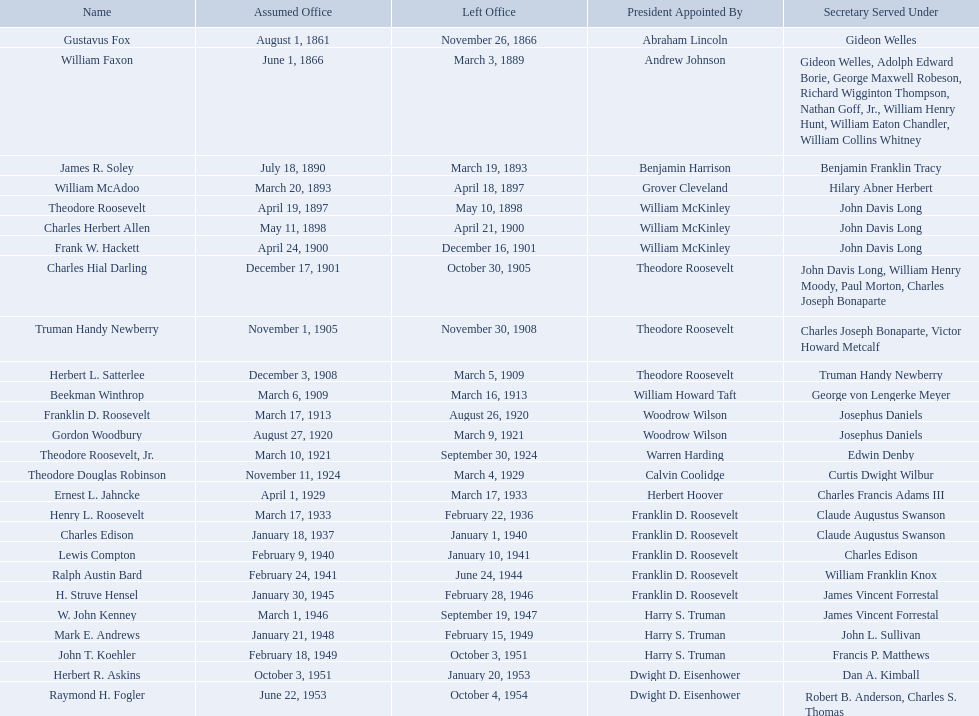Who were all the assistant secretary's of the navy? Gustavus Fox, William Faxon, James R. Soley, William McAdoo, Theodore Roosevelt, Charles Herbert Allen, Frank W. Hackett, Charles Hial Darling, Truman Handy Newberry, Herbert L. Satterlee, Beekman Winthrop, Franklin D. Roosevelt, Gordon Woodbury, Theodore Roosevelt, Jr., Theodore Douglas Robinson, Ernest L. Jahncke, Henry L. Roosevelt, Charles Edison, Lewis Compton, Ralph Austin Bard, H. Struve Hensel, W. John Kenney, Mark E. Andrews, John T. Koehler, Herbert R. Askins, Raymond H. Fogler. What are the various dates they left office in? November 26, 1866, March 3, 1889, March 19, 1893, April 18, 1897, May 10, 1898, April 21, 1900, December 16, 1901, October 30, 1905, November 30, 1908, March 5, 1909, March 16, 1913, August 26, 1920, March 9, 1921, September 30, 1924, March 4, 1929, March 17, 1933, February 22, 1936, January 1, 1940, January 10, 1941, June 24, 1944, February 28, 1946, September 19, 1947, February 15, 1949, October 3, 1951, January 20, 1953, October 4, 1954. Of these dates, which was the date raymond h. fogler left office in? October 4, 1954. Who were all the assistant secretaries of the navy throughout the 20th century? Charles Herbert Allen, Frank W. Hackett, Charles Hial Darling, Truman Handy Newberry, Herbert L. Satterlee, Beekman Winthrop, Franklin D. Roosevelt, Gordon Woodbury, Theodore Roosevelt, Jr., Theodore Douglas Robinson, Ernest L. Jahncke, Henry L. Roosevelt, Charles Edison, Lewis Compton, Ralph Austin Bard, H. Struve Hensel, W. John Kenney, Mark E. Andrews, John T. Koehler, Herbert R. Askins, Raymond H. Fogler. When was assistant secretary of the navy raymond h. fogler appointed to his position? June 22, 1953. When did assistant secretary of the navy raymond h. fogler step down from his role? October 4, 1954. Can you list the assistant secretaries of the navy from the 20th century? Charles Herbert Allen, Frank W. Hackett, Charles Hial Darling, Truman Handy Newberry, Herbert L. Satterlee, Beekman Winthrop, Franklin D. Roosevelt, Gordon Woodbury, Theodore Roosevelt, Jr., Theodore Douglas Robinson, Ernest L. Jahncke, Henry L. Roosevelt, Charles Edison, Lewis Compton, Ralph Austin Bard, H. Struve Hensel, W. John Kenney, Mark E. Andrews, John T. Koehler, Herbert R. Askins, Raymond H. Fogler. When was raymond h. fogler's appointment as assistant secretary of the navy? June 22, 1953. When did he depart from this position? October 4, 1954. What are the complete names? Gustavus Fox, William Faxon, James R. Soley, William McAdoo, Theodore Roosevelt, Charles Herbert Allen, Frank W. Hackett, Charles Hial Darling, Truman Handy Newberry, Herbert L. Satterlee, Beekman Winthrop, Franklin D. Roosevelt, Gordon Woodbury, Theodore Roosevelt, Jr., Theodore Douglas Robinson, Ernest L. Jahncke, Henry L. Roosevelt, Charles Edison, Lewis Compton, Ralph Austin Bard, H. Struve Hensel, W. John Kenney, Mark E. Andrews, John T. Koehler, Herbert R. Askins, Raymond H. Fogler. When was their term in office finished? November 26, 1866, March 3, 1889, March 19, 1893, April 18, 1897, May 10, 1898, April 21, 1900, December 16, 1901, October 30, 1905, November 30, 1908, March 5, 1909, March 16, 1913, August 26, 1920, March 9, 1921, September 30, 1924, March 4, 1929, March 17, 1933, February 22, 1936, January 1, 1940, January 10, 1941, June 24, 1944, February 28, 1946, September 19, 1947, February 15, 1949, October 3, 1951, January 20, 1953, October 4, 1954. And when did raymond h. fogler depart? October 4, 1954. Can you provide the full names? Gustavus Fox, William Faxon, James R. Soley, William McAdoo, Theodore Roosevelt, Charles Herbert Allen, Frank W. Hackett, Charles Hial Darling, Truman Handy Newberry, Herbert L. Satterlee, Beekman Winthrop, Franklin D. Roosevelt, Gordon Woodbury, Theodore Roosevelt, Jr., Theodore Douglas Robinson, Ernest L. Jahncke, Henry L. Roosevelt, Charles Edison, Lewis Compton, Ralph Austin Bard, H. Struve Hensel, W. John Kenney, Mark E. Andrews, John T. Koehler, Herbert R. Askins, Raymond H. Fogler. Would you be able to parse every entry in this table? {'header': ['Name', 'Assumed Office', 'Left Office', 'President Appointed By', 'Secretary Served Under'], 'rows': [['Gustavus Fox', 'August 1, 1861', 'November 26, 1866', 'Abraham Lincoln', 'Gideon Welles'], ['William Faxon', 'June 1, 1866', 'March 3, 1889', 'Andrew Johnson', 'Gideon Welles, Adolph Edward Borie, George Maxwell Robeson, Richard Wigginton Thompson, Nathan Goff, Jr., William Henry Hunt, William Eaton Chandler, William Collins Whitney'], ['James R. Soley', 'July 18, 1890', 'March 19, 1893', 'Benjamin Harrison', 'Benjamin Franklin Tracy'], ['William McAdoo', 'March 20, 1893', 'April 18, 1897', 'Grover Cleveland', 'Hilary Abner Herbert'], ['Theodore Roosevelt', 'April 19, 1897', 'May 10, 1898', 'William McKinley', 'John Davis Long'], ['Charles Herbert Allen', 'May 11, 1898', 'April 21, 1900', 'William McKinley', 'John Davis Long'], ['Frank W. Hackett', 'April 24, 1900', 'December 16, 1901', 'William McKinley', 'John Davis Long'], ['Charles Hial Darling', 'December 17, 1901', 'October 30, 1905', 'Theodore Roosevelt', 'John Davis Long, William Henry Moody, Paul Morton, Charles Joseph Bonaparte'], ['Truman Handy Newberry', 'November 1, 1905', 'November 30, 1908', 'Theodore Roosevelt', 'Charles Joseph Bonaparte, Victor Howard Metcalf'], ['Herbert L. Satterlee', 'December 3, 1908', 'March 5, 1909', 'Theodore Roosevelt', 'Truman Handy Newberry'], ['Beekman Winthrop', 'March 6, 1909', 'March 16, 1913', 'William Howard Taft', 'George von Lengerke Meyer'], ['Franklin D. Roosevelt', 'March 17, 1913', 'August 26, 1920', 'Woodrow Wilson', 'Josephus Daniels'], ['Gordon Woodbury', 'August 27, 1920', 'March 9, 1921', 'Woodrow Wilson', 'Josephus Daniels'], ['Theodore Roosevelt, Jr.', 'March 10, 1921', 'September 30, 1924', 'Warren Harding', 'Edwin Denby'], ['Theodore Douglas Robinson', 'November 11, 1924', 'March 4, 1929', 'Calvin Coolidge', 'Curtis Dwight Wilbur'], ['Ernest L. Jahncke', 'April 1, 1929', 'March 17, 1933', 'Herbert Hoover', 'Charles Francis Adams III'], ['Henry L. Roosevelt', 'March 17, 1933', 'February 22, 1936', 'Franklin D. Roosevelt', 'Claude Augustus Swanson'], ['Charles Edison', 'January 18, 1937', 'January 1, 1940', 'Franklin D. Roosevelt', 'Claude Augustus Swanson'], ['Lewis Compton', 'February 9, 1940', 'January 10, 1941', 'Franklin D. Roosevelt', 'Charles Edison'], ['Ralph Austin Bard', 'February 24, 1941', 'June 24, 1944', 'Franklin D. Roosevelt', 'William Franklin Knox'], ['H. Struve Hensel', 'January 30, 1945', 'February 28, 1946', 'Franklin D. Roosevelt', 'James Vincent Forrestal'], ['W. John Kenney', 'March 1, 1946', 'September 19, 1947', 'Harry S. Truman', 'James Vincent Forrestal'], ['Mark E. Andrews', 'January 21, 1948', 'February 15, 1949', 'Harry S. Truman', 'John L. Sullivan'], ['John T. Koehler', 'February 18, 1949', 'October 3, 1951', 'Harry S. Truman', 'Francis P. Matthews'], ['Herbert R. Askins', 'October 3, 1951', 'January 20, 1953', 'Dwight D. Eisenhower', 'Dan A. Kimball'], ['Raymond H. Fogler', 'June 22, 1953', 'October 4, 1954', 'Dwight D. Eisenhower', 'Robert B. Anderson, Charles S. Thomas']]} When did their tenure end? November 26, 1866, March 3, 1889, March 19, 1893, April 18, 1897, May 10, 1898, April 21, 1900, December 16, 1901, October 30, 1905, November 30, 1908, March 5, 1909, March 16, 1913, August 26, 1920, March 9, 1921, September 30, 1924, March 4, 1929, March 17, 1933, February 22, 1936, January 1, 1940, January 10, 1941, June 24, 1944, February 28, 1946, September 19, 1947, February 15, 1949, October 3, 1951, January 20, 1953, October 4, 1954. Also, when did raymond h. fogler's time conclude? October 4, 1954. 